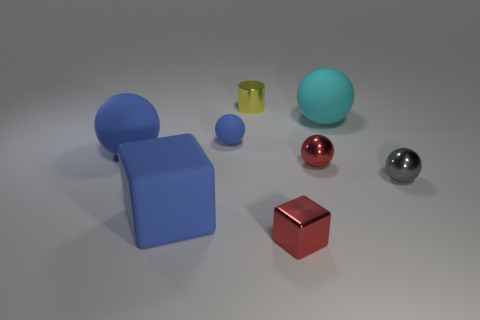Is there a blue ball that is on the right side of the big rubber object to the right of the small red object in front of the large rubber cube?
Offer a very short reply. No. What is the color of the small shiny block?
Offer a very short reply. Red. What is the color of the cylinder that is the same size as the red metal cube?
Make the answer very short. Yellow. There is a big blue object that is behind the large blue rubber cube; does it have the same shape as the gray metal thing?
Give a very brief answer. Yes. There is a big sphere that is in front of the matte object to the right of the small shiny object in front of the tiny gray ball; what color is it?
Make the answer very short. Blue. Are any gray metal spheres visible?
Your response must be concise. Yes. How many other things are there of the same size as the cylinder?
Provide a succinct answer. 4. Is the color of the shiny cylinder the same as the matte thing to the right of the metal cube?
Give a very brief answer. No. What number of things are tiny purple matte balls or tiny gray shiny balls?
Ensure brevity in your answer.  1. Is there anything else of the same color as the shiny block?
Give a very brief answer. Yes. 